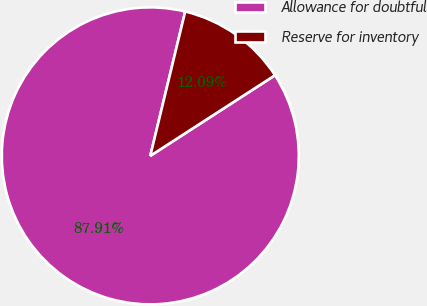Convert chart. <chart><loc_0><loc_0><loc_500><loc_500><pie_chart><fcel>Allowance for doubtful<fcel>Reserve for inventory<nl><fcel>87.91%<fcel>12.09%<nl></chart> 